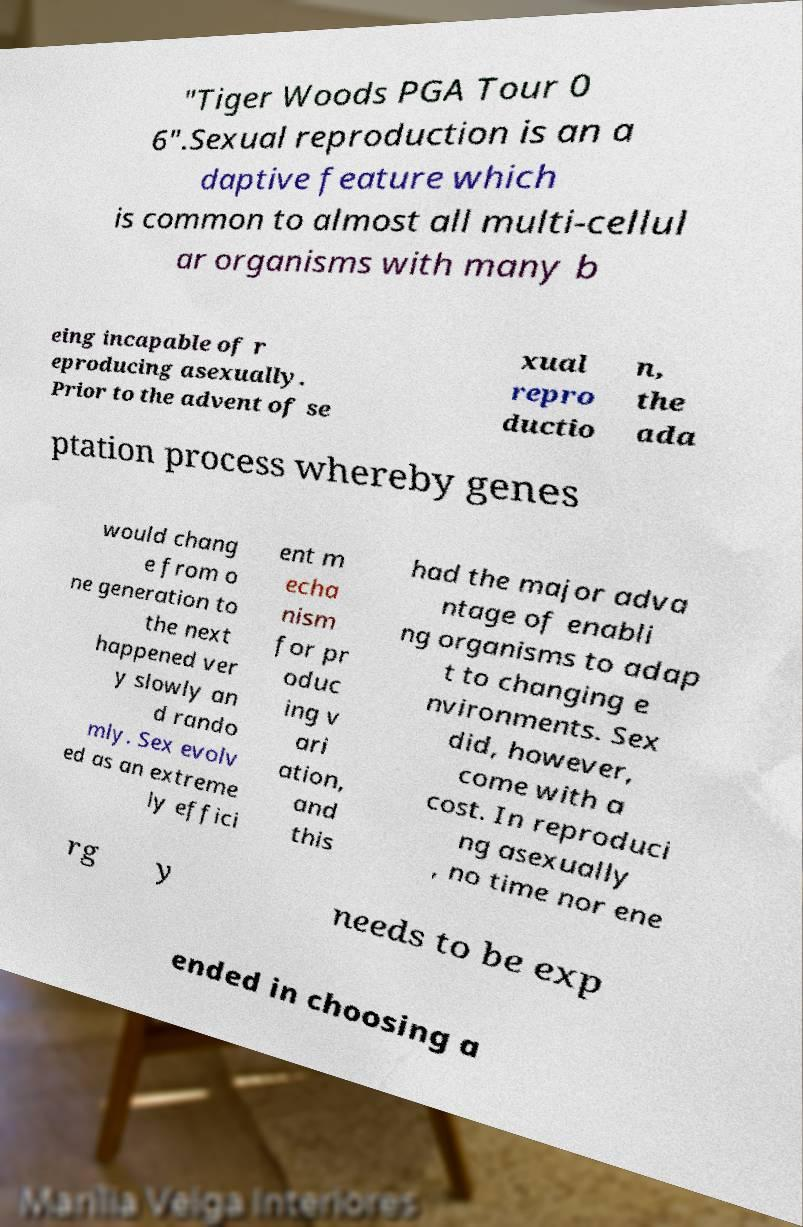For documentation purposes, I need the text within this image transcribed. Could you provide that? "Tiger Woods PGA Tour 0 6".Sexual reproduction is an a daptive feature which is common to almost all multi-cellul ar organisms with many b eing incapable of r eproducing asexually. Prior to the advent of se xual repro ductio n, the ada ptation process whereby genes would chang e from o ne generation to the next happened ver y slowly an d rando mly. Sex evolv ed as an extreme ly effici ent m echa nism for pr oduc ing v ari ation, and this had the major adva ntage of enabli ng organisms to adap t to changing e nvironments. Sex did, however, come with a cost. In reproduci ng asexually , no time nor ene rg y needs to be exp ended in choosing a 